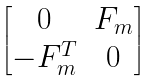Convert formula to latex. <formula><loc_0><loc_0><loc_500><loc_500>\begin{bmatrix} 0 & F _ { m } \\ - F _ { m } ^ { T } & 0 \\ \end{bmatrix}</formula> 